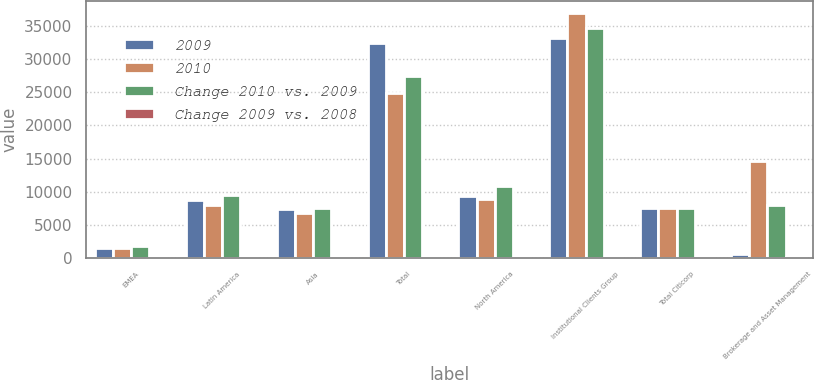Convert chart. <chart><loc_0><loc_0><loc_500><loc_500><stacked_bar_chart><ecel><fcel>EMEA<fcel>Latin America<fcel>Asia<fcel>Total<fcel>North America<fcel>Institutional Clients Group<fcel>Total Citicorp<fcel>Brokerage and Asset Management<nl><fcel>2009<fcel>1511<fcel>8727<fcel>7414<fcel>32442<fcel>9392<fcel>33118<fcel>7461<fcel>609<nl><fcel>2010<fcel>1555<fcel>7917<fcel>6766<fcel>24814<fcel>8833<fcel>36898<fcel>7461<fcel>14623<nl><fcel>Change 2010 vs. 2009<fcel>1865<fcel>9488<fcel>7461<fcel>27421<fcel>10821<fcel>34674<fcel>7461<fcel>7963<nl><fcel>Change 2009 vs. 2008<fcel>3<fcel>10<fcel>10<fcel>31<fcel>6<fcel>10<fcel>6<fcel>96<nl></chart> 